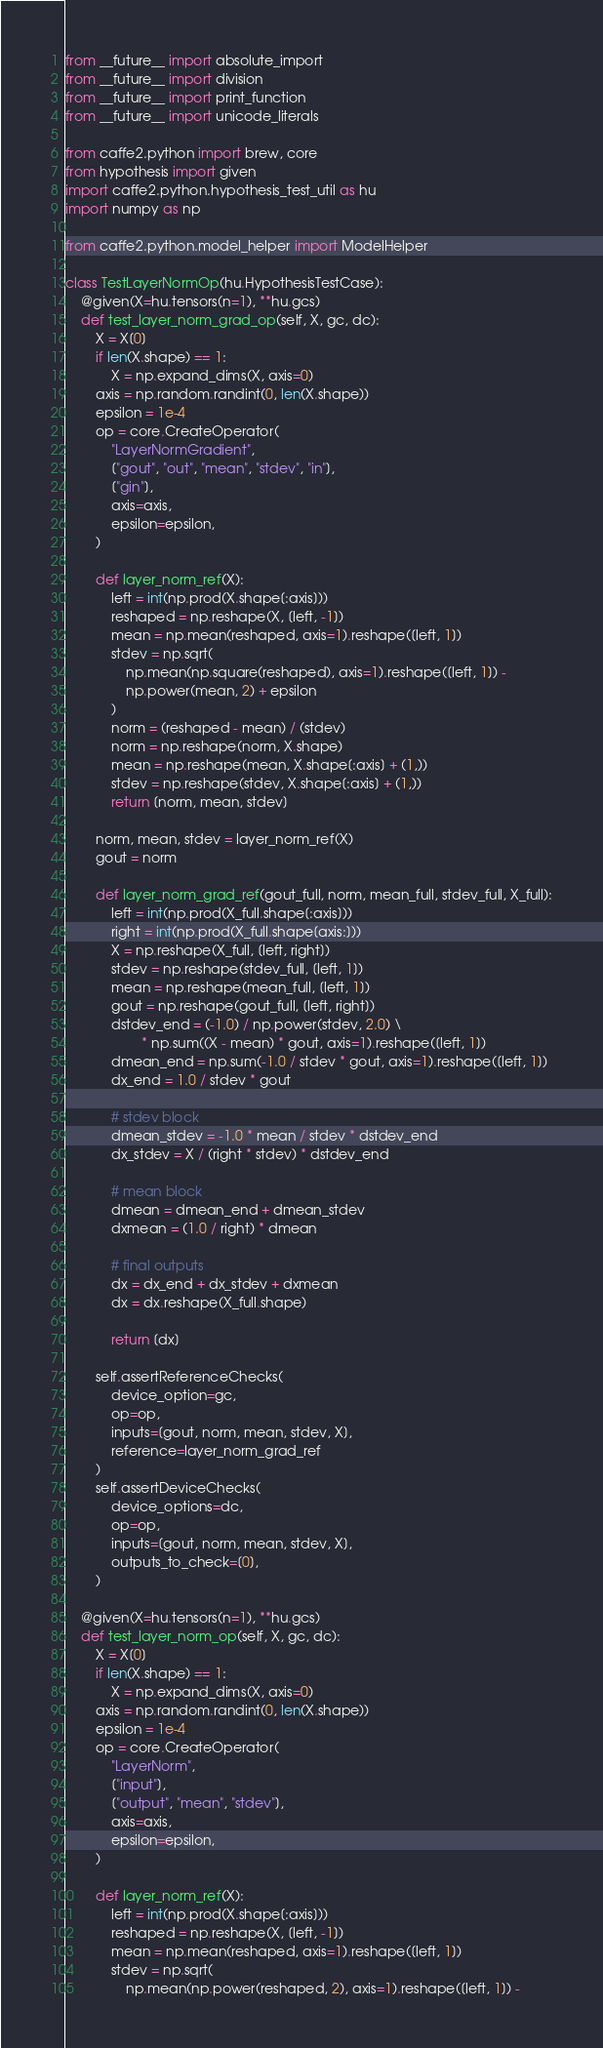<code> <loc_0><loc_0><loc_500><loc_500><_Python_>from __future__ import absolute_import
from __future__ import division
from __future__ import print_function
from __future__ import unicode_literals

from caffe2.python import brew, core
from hypothesis import given
import caffe2.python.hypothesis_test_util as hu
import numpy as np

from caffe2.python.model_helper import ModelHelper

class TestLayerNormOp(hu.HypothesisTestCase):
    @given(X=hu.tensors(n=1), **hu.gcs)
    def test_layer_norm_grad_op(self, X, gc, dc):
        X = X[0]
        if len(X.shape) == 1:
            X = np.expand_dims(X, axis=0)
        axis = np.random.randint(0, len(X.shape))
        epsilon = 1e-4
        op = core.CreateOperator(
            "LayerNormGradient",
            ["gout", "out", "mean", "stdev", "in"],
            ["gin"],
            axis=axis,
            epsilon=epsilon,
        )

        def layer_norm_ref(X):
            left = int(np.prod(X.shape[:axis]))
            reshaped = np.reshape(X, [left, -1])
            mean = np.mean(reshaped, axis=1).reshape([left, 1])
            stdev = np.sqrt(
                np.mean(np.square(reshaped), axis=1).reshape([left, 1]) -
                np.power(mean, 2) + epsilon
            )
            norm = (reshaped - mean) / (stdev)
            norm = np.reshape(norm, X.shape)
            mean = np.reshape(mean, X.shape[:axis] + (1,))
            stdev = np.reshape(stdev, X.shape[:axis] + (1,))
            return [norm, mean, stdev]

        norm, mean, stdev = layer_norm_ref(X)
        gout = norm

        def layer_norm_grad_ref(gout_full, norm, mean_full, stdev_full, X_full):
            left = int(np.prod(X_full.shape[:axis]))
            right = int(np.prod(X_full.shape[axis:]))
            X = np.reshape(X_full, [left, right])
            stdev = np.reshape(stdev_full, [left, 1])
            mean = np.reshape(mean_full, [left, 1])
            gout = np.reshape(gout_full, [left, right])
            dstdev_end = (-1.0) / np.power(stdev, 2.0) \
                    * np.sum((X - mean) * gout, axis=1).reshape([left, 1])
            dmean_end = np.sum(-1.0 / stdev * gout, axis=1).reshape([left, 1])
            dx_end = 1.0 / stdev * gout

            # stdev block
            dmean_stdev = -1.0 * mean / stdev * dstdev_end
            dx_stdev = X / (right * stdev) * dstdev_end

            # mean block
            dmean = dmean_end + dmean_stdev
            dxmean = (1.0 / right) * dmean

            # final outputs
            dx = dx_end + dx_stdev + dxmean
            dx = dx.reshape(X_full.shape)

            return [dx]

        self.assertReferenceChecks(
            device_option=gc,
            op=op,
            inputs=[gout, norm, mean, stdev, X],
            reference=layer_norm_grad_ref
        )
        self.assertDeviceChecks(
            device_options=dc,
            op=op,
            inputs=[gout, norm, mean, stdev, X],
            outputs_to_check=[0],
        )

    @given(X=hu.tensors(n=1), **hu.gcs)
    def test_layer_norm_op(self, X, gc, dc):
        X = X[0]
        if len(X.shape) == 1:
            X = np.expand_dims(X, axis=0)
        axis = np.random.randint(0, len(X.shape))
        epsilon = 1e-4
        op = core.CreateOperator(
            "LayerNorm",
            ["input"],
            ["output", "mean", "stdev"],
            axis=axis,
            epsilon=epsilon,
        )

        def layer_norm_ref(X):
            left = int(np.prod(X.shape[:axis]))
            reshaped = np.reshape(X, [left, -1])
            mean = np.mean(reshaped, axis=1).reshape([left, 1])
            stdev = np.sqrt(
                np.mean(np.power(reshaped, 2), axis=1).reshape([left, 1]) -</code> 